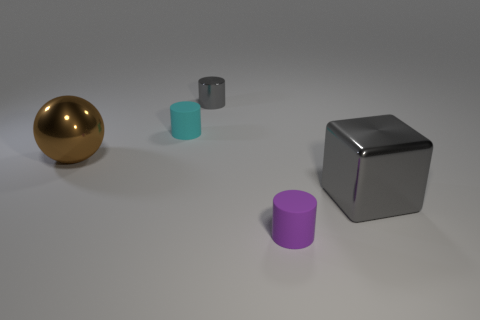What shape is the tiny metallic object that is the same color as the metal cube?
Your response must be concise. Cylinder. What color is the large ball?
Provide a short and direct response. Brown. Is there a large cube that has the same color as the ball?
Ensure brevity in your answer.  No. The cylinder that is the same color as the large metallic cube is what size?
Keep it short and to the point. Small. The brown thing is what shape?
Your response must be concise. Sphere. The matte object in front of the large object on the left side of the thing to the right of the small purple rubber thing is what shape?
Provide a short and direct response. Cylinder. What number of other things are the same shape as the large gray shiny thing?
Your answer should be compact. 0. What is the material of the object that is on the left side of the tiny cylinder left of the tiny gray metal object?
Make the answer very short. Metal. Is there any other thing that is the same size as the brown metal thing?
Offer a very short reply. Yes. Is the material of the small cyan cylinder the same as the big gray block that is on the right side of the gray cylinder?
Keep it short and to the point. No. 